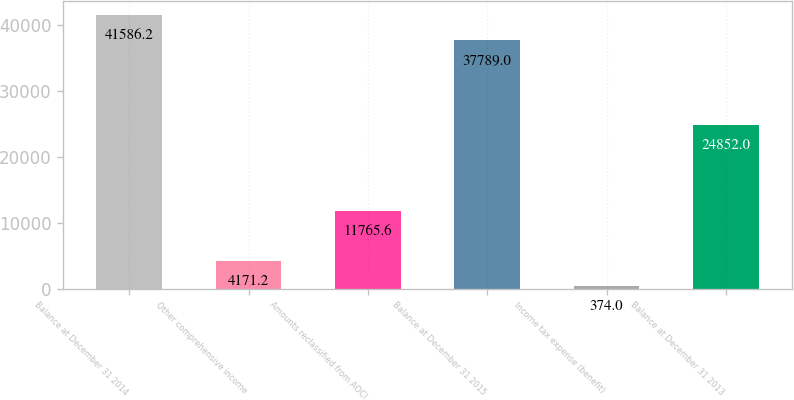<chart> <loc_0><loc_0><loc_500><loc_500><bar_chart><fcel>Balance at December 31 2014<fcel>Other comprehensive income<fcel>Amounts reclassified from AOCI<fcel>Balance at December 31 2015<fcel>Income tax expense (benefit)<fcel>Balance at December 31 2013<nl><fcel>41586.2<fcel>4171.2<fcel>11765.6<fcel>37789<fcel>374<fcel>24852<nl></chart> 